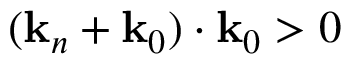<formula> <loc_0><loc_0><loc_500><loc_500>( k _ { n } + k _ { 0 } ) \cdot k _ { 0 } > 0</formula> 